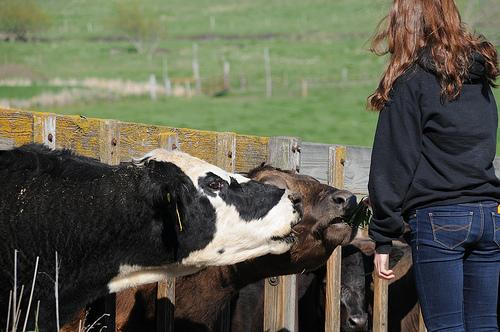List the dominant colors in the image related to objects and their surroundings. Dominant colors include blue jeans, green grass, brown hair, black hoodie, and yellow wood remnants. How many cows are visible in the image and what fur colors do they have? There are three cows: one black and white, one dark brown, and one with fluffy fur. What is the overall setting of the image and the time of day it was taken? The image is set in a grassy hill with a cow pen and trees, and it was taken during the day. Describe the woman's clothing and hair in the image. The woman has long brown hair and is wearing a black hoodie and blue jeans. What is unique about the brown cow among the other cows in the image? The brown cow has a brown eye visible in the image. Count the number of objects made of wood in the image and describe them briefly. There are four wooden objects in the image: a pen, fence posts, poles, and a wooden fence around the pen. What interaction is happening between the woman and the cows? The woman is holding a plant in her right hand, and the cows are trying to eat the plant. Mention the status of the wooden fence and paint, if any, in the image. The fence is old, wooden, and has remnants of yellow paint on it. What color are the jeans worn by the woman in the image? The jeans worn by the woman are blue. What type of fence surrounds the pen with the cows? A wooden fence, with remnants of yellow paint, surrounds the pen with the cows. Is the woman wearing a red polka-dot dress instead of a hoodie? No, it's not mentioned in the image. Are the cows purple with orange spots in the image? The cows in the image are described as black and white, black, or brown, but never purple with orange spots. Therefore, this question is misleading. Can you find a green wooden fence surrounding the cows in the image? There is mention of a wooden fence, but it is described as having remnants of yellow paint, not green paint. Thus, suggesting a green wooden fence is misleading. Do the trees in the image have only blue leaves? There is no mention of trees with blue leaves in the image. There is a mention of trees on a grassy pen, but the color of the leaves isn't specified. Asking about blue leaves is misleading. Is the lady's hair blond and short in the photo? The instructions related to the lady's hair all mention long brown hair, so mentioning blond and short hair is misleading. Are the jeans on the woman pink and tight? The instructions related to the jeans mention blue jeans, making the mention of pink and tight jeans misleading. 